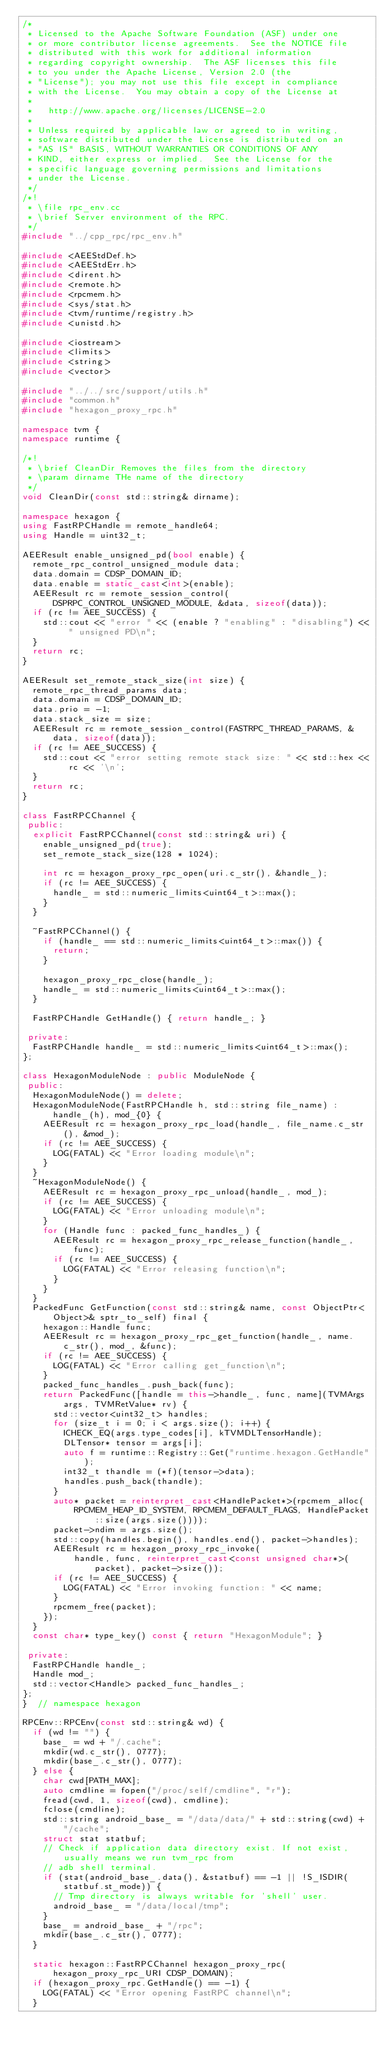Convert code to text. <code><loc_0><loc_0><loc_500><loc_500><_C++_>/*
 * Licensed to the Apache Software Foundation (ASF) under one
 * or more contributor license agreements.  See the NOTICE file
 * distributed with this work for additional information
 * regarding copyright ownership.  The ASF licenses this file
 * to you under the Apache License, Version 2.0 (the
 * "License"); you may not use this file except in compliance
 * with the License.  You may obtain a copy of the License at
 *
 *   http://www.apache.org/licenses/LICENSE-2.0
 *
 * Unless required by applicable law or agreed to in writing,
 * software distributed under the License is distributed on an
 * "AS IS" BASIS, WITHOUT WARRANTIES OR CONDITIONS OF ANY
 * KIND, either express or implied.  See the License for the
 * specific language governing permissions and limitations
 * under the License.
 */
/*!
 * \file rpc_env.cc
 * \brief Server environment of the RPC.
 */
#include "../cpp_rpc/rpc_env.h"

#include <AEEStdDef.h>
#include <AEEStdErr.h>
#include <dirent.h>
#include <remote.h>
#include <rpcmem.h>
#include <sys/stat.h>
#include <tvm/runtime/registry.h>
#include <unistd.h>

#include <iostream>
#include <limits>
#include <string>
#include <vector>

#include "../../src/support/utils.h"
#include "common.h"
#include "hexagon_proxy_rpc.h"

namespace tvm {
namespace runtime {

/*!
 * \brief CleanDir Removes the files from the directory
 * \param dirname THe name of the directory
 */
void CleanDir(const std::string& dirname);

namespace hexagon {
using FastRPCHandle = remote_handle64;
using Handle = uint32_t;

AEEResult enable_unsigned_pd(bool enable) {
  remote_rpc_control_unsigned_module data;
  data.domain = CDSP_DOMAIN_ID;
  data.enable = static_cast<int>(enable);
  AEEResult rc = remote_session_control(DSPRPC_CONTROL_UNSIGNED_MODULE, &data, sizeof(data));
  if (rc != AEE_SUCCESS) {
    std::cout << "error " << (enable ? "enabling" : "disabling") << " unsigned PD\n";
  }
  return rc;
}

AEEResult set_remote_stack_size(int size) {
  remote_rpc_thread_params data;
  data.domain = CDSP_DOMAIN_ID;
  data.prio = -1;
  data.stack_size = size;
  AEEResult rc = remote_session_control(FASTRPC_THREAD_PARAMS, &data, sizeof(data));
  if (rc != AEE_SUCCESS) {
    std::cout << "error setting remote stack size: " << std::hex << rc << '\n';
  }
  return rc;
}

class FastRPCChannel {
 public:
  explicit FastRPCChannel(const std::string& uri) {
    enable_unsigned_pd(true);
    set_remote_stack_size(128 * 1024);

    int rc = hexagon_proxy_rpc_open(uri.c_str(), &handle_);
    if (rc != AEE_SUCCESS) {
      handle_ = std::numeric_limits<uint64_t>::max();
    }
  }

  ~FastRPCChannel() {
    if (handle_ == std::numeric_limits<uint64_t>::max()) {
      return;
    }

    hexagon_proxy_rpc_close(handle_);
    handle_ = std::numeric_limits<uint64_t>::max();
  }

  FastRPCHandle GetHandle() { return handle_; }

 private:
  FastRPCHandle handle_ = std::numeric_limits<uint64_t>::max();
};

class HexagonModuleNode : public ModuleNode {
 public:
  HexagonModuleNode() = delete;
  HexagonModuleNode(FastRPCHandle h, std::string file_name) : handle_(h), mod_{0} {
    AEEResult rc = hexagon_proxy_rpc_load(handle_, file_name.c_str(), &mod_);
    if (rc != AEE_SUCCESS) {
      LOG(FATAL) << "Error loading module\n";
    }
  }
  ~HexagonModuleNode() {
    AEEResult rc = hexagon_proxy_rpc_unload(handle_, mod_);
    if (rc != AEE_SUCCESS) {
      LOG(FATAL) << "Error unloading module\n";
    }
    for (Handle func : packed_func_handles_) {
      AEEResult rc = hexagon_proxy_rpc_release_function(handle_, func);
      if (rc != AEE_SUCCESS) {
        LOG(FATAL) << "Error releasing function\n";
      }
    }
  }
  PackedFunc GetFunction(const std::string& name, const ObjectPtr<Object>& sptr_to_self) final {
    hexagon::Handle func;
    AEEResult rc = hexagon_proxy_rpc_get_function(handle_, name.c_str(), mod_, &func);
    if (rc != AEE_SUCCESS) {
      LOG(FATAL) << "Error calling get_function\n";
    }
    packed_func_handles_.push_back(func);
    return PackedFunc([handle = this->handle_, func, name](TVMArgs args, TVMRetValue* rv) {
      std::vector<uint32_t> handles;
      for (size_t i = 0; i < args.size(); i++) {
        ICHECK_EQ(args.type_codes[i], kTVMDLTensorHandle);
        DLTensor* tensor = args[i];
        auto f = runtime::Registry::Get("runtime.hexagon.GetHandle");
        int32_t thandle = (*f)(tensor->data);
        handles.push_back(thandle);
      }
      auto* packet = reinterpret_cast<HandlePacket*>(rpcmem_alloc(
          RPCMEM_HEAP_ID_SYSTEM, RPCMEM_DEFAULT_FLAGS, HandlePacket::size(args.size())));
      packet->ndim = args.size();
      std::copy(handles.begin(), handles.end(), packet->handles);
      AEEResult rc = hexagon_proxy_rpc_invoke(
          handle, func, reinterpret_cast<const unsigned char*>(packet), packet->size());
      if (rc != AEE_SUCCESS) {
        LOG(FATAL) << "Error invoking function: " << name;
      }
      rpcmem_free(packet);
    });
  }
  const char* type_key() const { return "HexagonModule"; }

 private:
  FastRPCHandle handle_;
  Handle mod_;
  std::vector<Handle> packed_func_handles_;
};
}  // namespace hexagon

RPCEnv::RPCEnv(const std::string& wd) {
  if (wd != "") {
    base_ = wd + "/.cache";
    mkdir(wd.c_str(), 0777);
    mkdir(base_.c_str(), 0777);
  } else {
    char cwd[PATH_MAX];
    auto cmdline = fopen("/proc/self/cmdline", "r");
    fread(cwd, 1, sizeof(cwd), cmdline);
    fclose(cmdline);
    std::string android_base_ = "/data/data/" + std::string(cwd) + "/cache";
    struct stat statbuf;
    // Check if application data directory exist. If not exist, usually means we run tvm_rpc from
    // adb shell terminal.
    if (stat(android_base_.data(), &statbuf) == -1 || !S_ISDIR(statbuf.st_mode)) {
      // Tmp directory is always writable for 'shell' user.
      android_base_ = "/data/local/tmp";
    }
    base_ = android_base_ + "/rpc";
    mkdir(base_.c_str(), 0777);
  }

  static hexagon::FastRPCChannel hexagon_proxy_rpc(hexagon_proxy_rpc_URI CDSP_DOMAIN);
  if (hexagon_proxy_rpc.GetHandle() == -1) {
    LOG(FATAL) << "Error opening FastRPC channel\n";
  }
</code> 